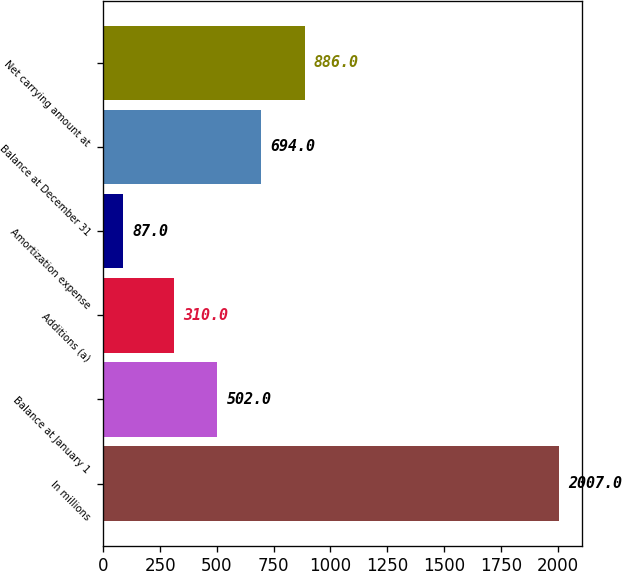Convert chart. <chart><loc_0><loc_0><loc_500><loc_500><bar_chart><fcel>In millions<fcel>Balance at January 1<fcel>Additions (a)<fcel>Amortization expense<fcel>Balance at December 31<fcel>Net carrying amount at<nl><fcel>2007<fcel>502<fcel>310<fcel>87<fcel>694<fcel>886<nl></chart> 